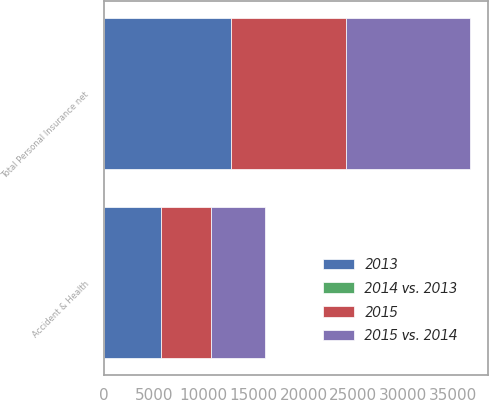<chart> <loc_0><loc_0><loc_500><loc_500><stacked_bar_chart><ecel><fcel>Accident & Health<fcel>Total Personal Insurance net<nl><fcel>2015<fcel>4990<fcel>11580<nl><fcel>2015 vs. 2014<fcel>5441<fcel>12412<nl><fcel>2013<fcel>5714<fcel>12700<nl><fcel>2014 vs. 2013<fcel>8<fcel>7<nl></chart> 